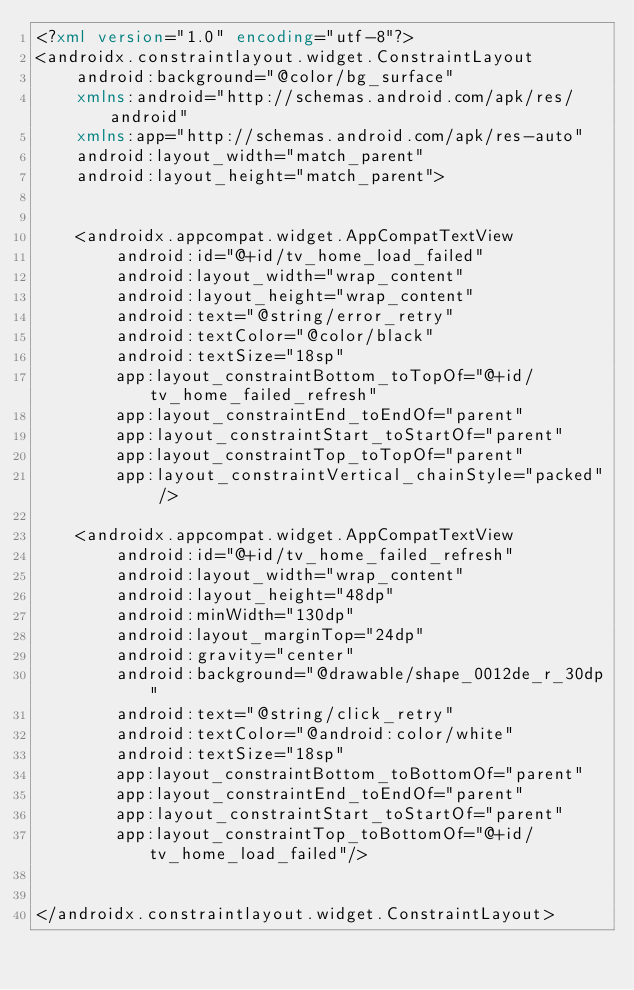Convert code to text. <code><loc_0><loc_0><loc_500><loc_500><_XML_><?xml version="1.0" encoding="utf-8"?>
<androidx.constraintlayout.widget.ConstraintLayout
    android:background="@color/bg_surface"
    xmlns:android="http://schemas.android.com/apk/res/android"
    xmlns:app="http://schemas.android.com/apk/res-auto"
    android:layout_width="match_parent"
    android:layout_height="match_parent">


    <androidx.appcompat.widget.AppCompatTextView
        android:id="@+id/tv_home_load_failed"
        android:layout_width="wrap_content"
        android:layout_height="wrap_content"
        android:text="@string/error_retry"
        android:textColor="@color/black"
        android:textSize="18sp"
        app:layout_constraintBottom_toTopOf="@+id/tv_home_failed_refresh"
        app:layout_constraintEnd_toEndOf="parent"
        app:layout_constraintStart_toStartOf="parent"
        app:layout_constraintTop_toTopOf="parent"
        app:layout_constraintVertical_chainStyle="packed" />

    <androidx.appcompat.widget.AppCompatTextView
        android:id="@+id/tv_home_failed_refresh"
        android:layout_width="wrap_content"
        android:layout_height="48dp"
        android:minWidth="130dp"
        android:layout_marginTop="24dp"
        android:gravity="center"
        android:background="@drawable/shape_0012de_r_30dp"
        android:text="@string/click_retry"
        android:textColor="@android:color/white"
        android:textSize="18sp"
        app:layout_constraintBottom_toBottomOf="parent"
        app:layout_constraintEnd_toEndOf="parent"
        app:layout_constraintStart_toStartOf="parent"
        app:layout_constraintTop_toBottomOf="@+id/tv_home_load_failed"/>


</androidx.constraintlayout.widget.ConstraintLayout></code> 